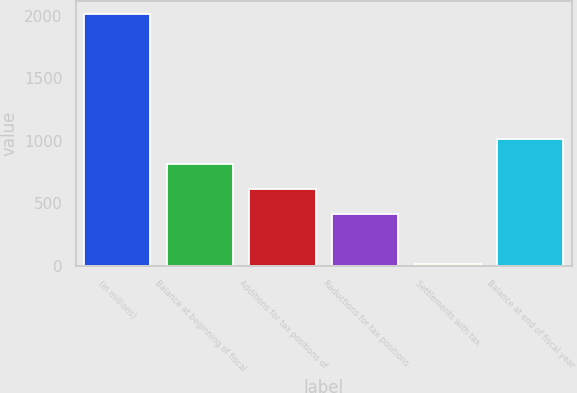<chart> <loc_0><loc_0><loc_500><loc_500><bar_chart><fcel>(in millions)<fcel>Balance at beginning of fiscal<fcel>Additions for tax positions of<fcel>Reductions for tax positions<fcel>Settlements with tax<fcel>Balance at end of fiscal year<nl><fcel>2015<fcel>812<fcel>611.5<fcel>411<fcel>10<fcel>1012.5<nl></chart> 